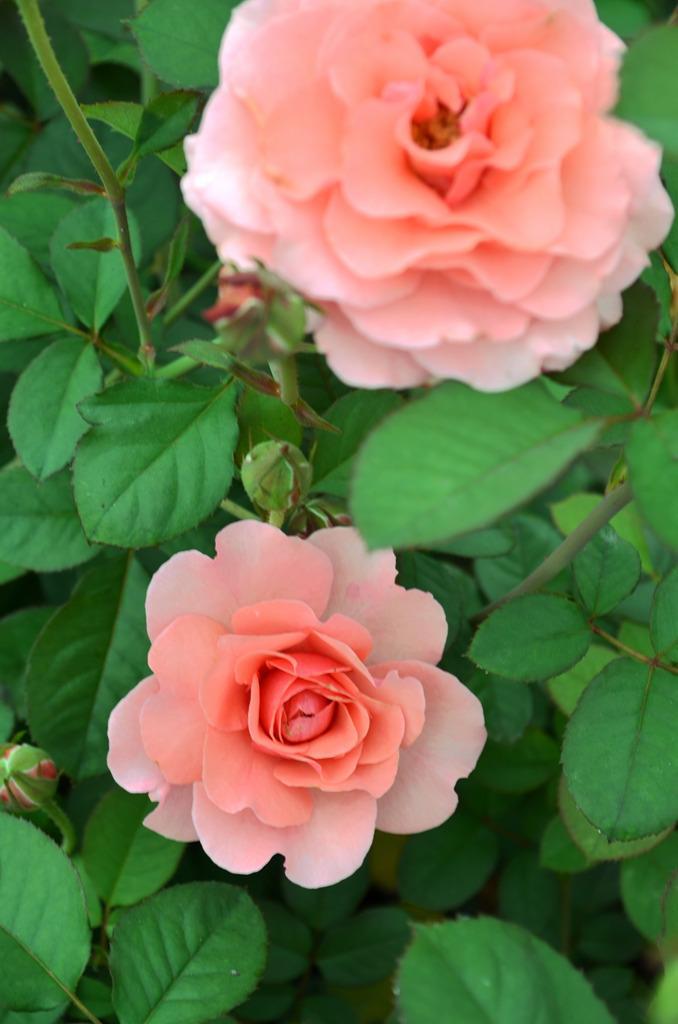Please provide a concise description of this image. In this picture there are two flower one in the middle and one at the top. 